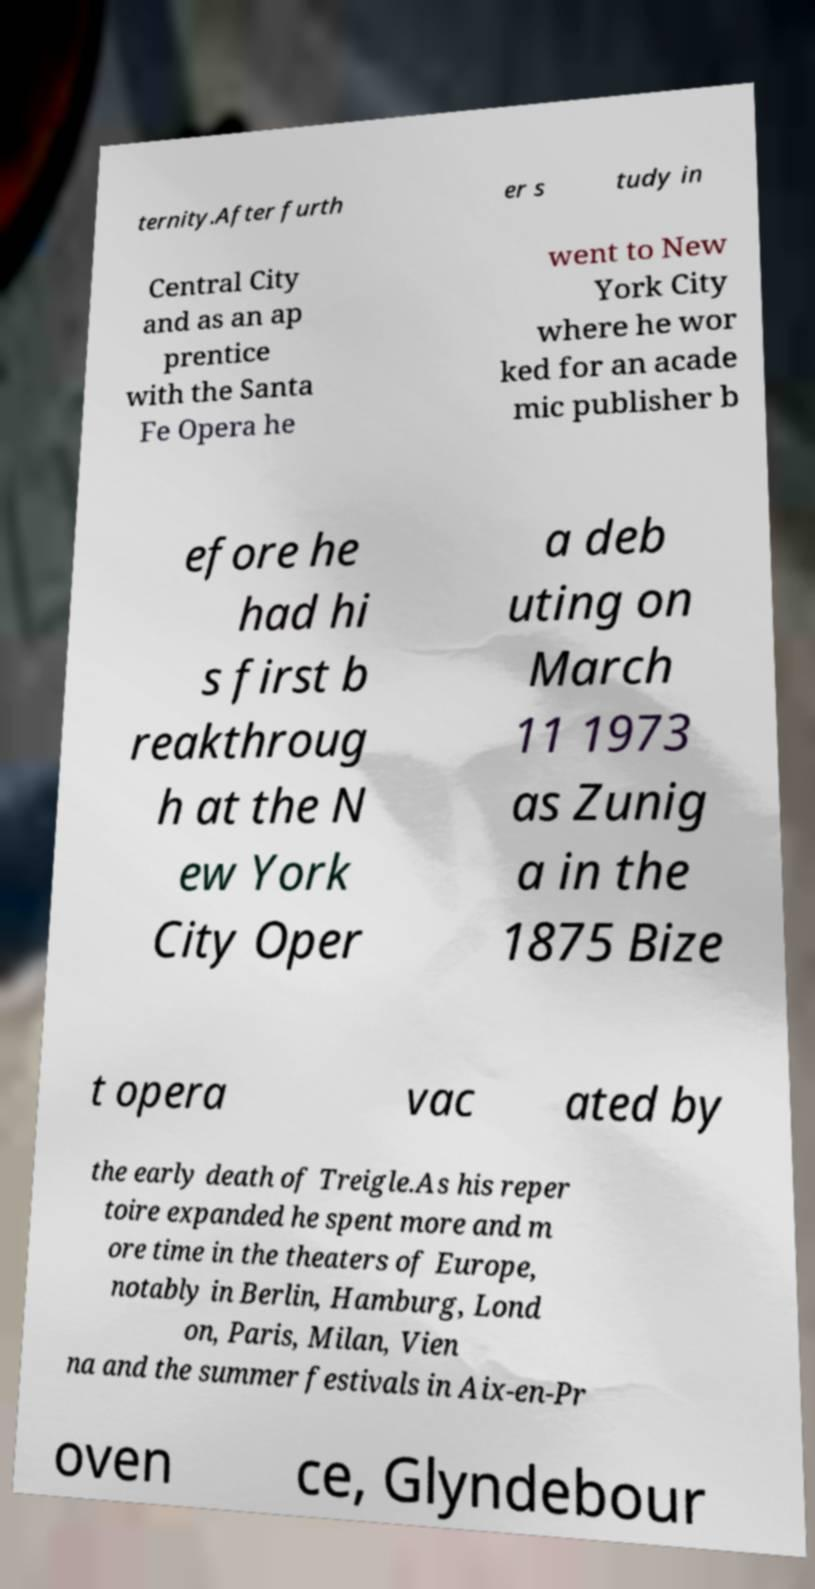I need the written content from this picture converted into text. Can you do that? ternity.After furth er s tudy in Central City and as an ap prentice with the Santa Fe Opera he went to New York City where he wor ked for an acade mic publisher b efore he had hi s first b reakthroug h at the N ew York City Oper a deb uting on March 11 1973 as Zunig a in the 1875 Bize t opera vac ated by the early death of Treigle.As his reper toire expanded he spent more and m ore time in the theaters of Europe, notably in Berlin, Hamburg, Lond on, Paris, Milan, Vien na and the summer festivals in Aix-en-Pr oven ce, Glyndebour 